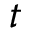<formula> <loc_0><loc_0><loc_500><loc_500>t</formula> 